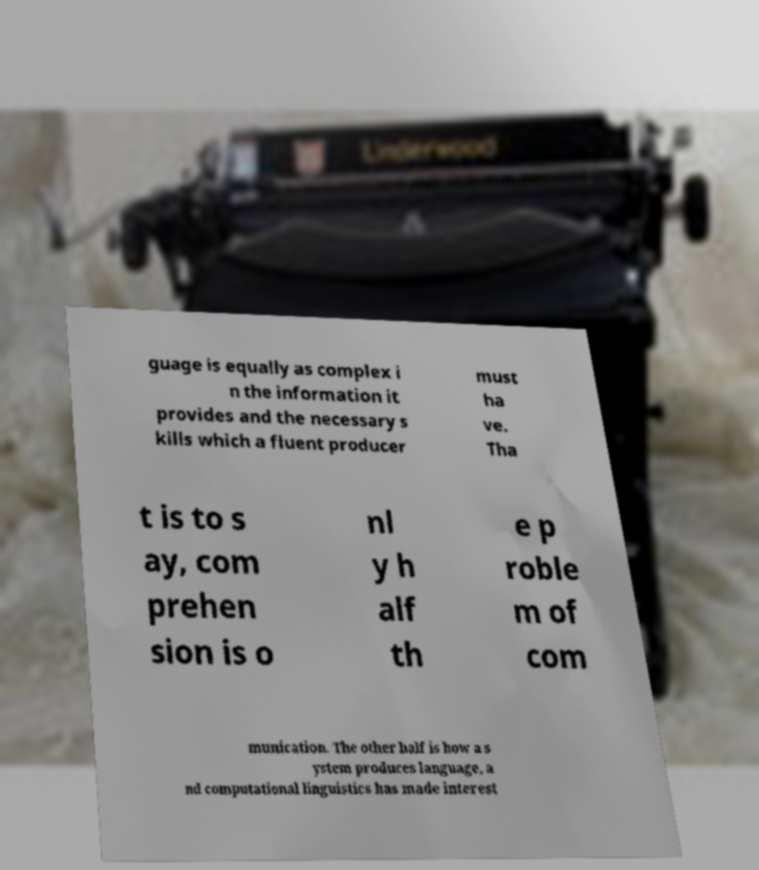Could you assist in decoding the text presented in this image and type it out clearly? guage is equally as complex i n the information it provides and the necessary s kills which a fluent producer must ha ve. Tha t is to s ay, com prehen sion is o nl y h alf th e p roble m of com munication. The other half is how a s ystem produces language, a nd computational linguistics has made interest 